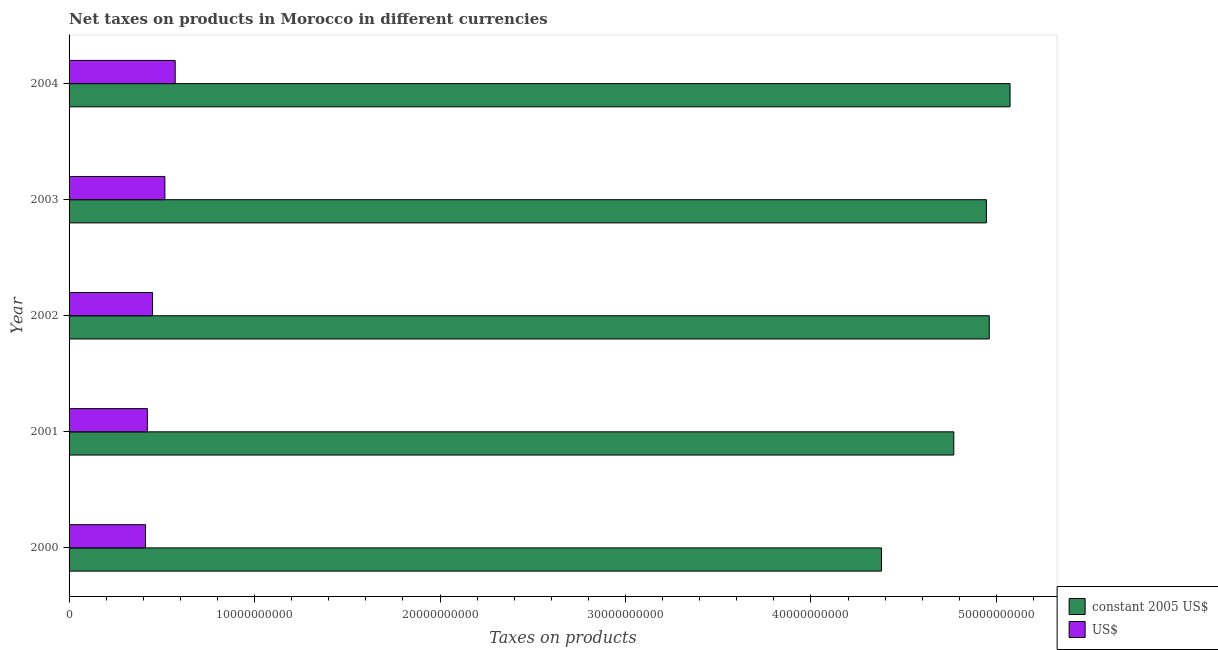How many different coloured bars are there?
Offer a terse response. 2. How many groups of bars are there?
Offer a very short reply. 5. Are the number of bars on each tick of the Y-axis equal?
Make the answer very short. Yes. What is the net taxes in us$ in 2001?
Keep it short and to the point. 4.22e+09. Across all years, what is the maximum net taxes in constant 2005 us$?
Offer a terse response. 5.07e+1. Across all years, what is the minimum net taxes in us$?
Offer a terse response. 4.12e+09. What is the total net taxes in constant 2005 us$ in the graph?
Provide a short and direct response. 2.41e+11. What is the difference between the net taxes in constant 2005 us$ in 2002 and that in 2004?
Offer a very short reply. -1.12e+09. What is the difference between the net taxes in constant 2005 us$ in 2002 and the net taxes in us$ in 2004?
Your response must be concise. 4.39e+1. What is the average net taxes in constant 2005 us$ per year?
Ensure brevity in your answer.  4.83e+1. In the year 2003, what is the difference between the net taxes in constant 2005 us$ and net taxes in us$?
Provide a succinct answer. 4.43e+1. In how many years, is the net taxes in us$ greater than 2000000000 units?
Keep it short and to the point. 5. What is the ratio of the net taxes in us$ in 2001 to that in 2003?
Keep it short and to the point. 0.82. Is the difference between the net taxes in us$ in 2000 and 2001 greater than the difference between the net taxes in constant 2005 us$ in 2000 and 2001?
Offer a very short reply. Yes. What is the difference between the highest and the second highest net taxes in constant 2005 us$?
Provide a short and direct response. 1.12e+09. What is the difference between the highest and the lowest net taxes in us$?
Your answer should be very brief. 1.60e+09. In how many years, is the net taxes in constant 2005 us$ greater than the average net taxes in constant 2005 us$ taken over all years?
Offer a terse response. 3. What does the 1st bar from the top in 2000 represents?
Offer a very short reply. US$. What does the 1st bar from the bottom in 2003 represents?
Keep it short and to the point. Constant 2005 us$. How many bars are there?
Make the answer very short. 10. Are all the bars in the graph horizontal?
Your answer should be compact. Yes. What is the difference between two consecutive major ticks on the X-axis?
Make the answer very short. 1.00e+1. Are the values on the major ticks of X-axis written in scientific E-notation?
Provide a succinct answer. No. Does the graph contain grids?
Your answer should be compact. No. Where does the legend appear in the graph?
Your response must be concise. Bottom right. What is the title of the graph?
Offer a very short reply. Net taxes on products in Morocco in different currencies. What is the label or title of the X-axis?
Offer a terse response. Taxes on products. What is the Taxes on products of constant 2005 US$ in 2000?
Give a very brief answer. 4.38e+1. What is the Taxes on products in US$ in 2000?
Your answer should be very brief. 4.12e+09. What is the Taxes on products in constant 2005 US$ in 2001?
Ensure brevity in your answer.  4.77e+1. What is the Taxes on products in US$ in 2001?
Your answer should be very brief. 4.22e+09. What is the Taxes on products in constant 2005 US$ in 2002?
Give a very brief answer. 4.96e+1. What is the Taxes on products of US$ in 2002?
Your answer should be very brief. 4.50e+09. What is the Taxes on products in constant 2005 US$ in 2003?
Offer a terse response. 4.95e+1. What is the Taxes on products in US$ in 2003?
Make the answer very short. 5.17e+09. What is the Taxes on products in constant 2005 US$ in 2004?
Provide a succinct answer. 5.07e+1. What is the Taxes on products of US$ in 2004?
Your answer should be very brief. 5.72e+09. Across all years, what is the maximum Taxes on products of constant 2005 US$?
Offer a very short reply. 5.07e+1. Across all years, what is the maximum Taxes on products in US$?
Your answer should be very brief. 5.72e+09. Across all years, what is the minimum Taxes on products of constant 2005 US$?
Make the answer very short. 4.38e+1. Across all years, what is the minimum Taxes on products of US$?
Offer a terse response. 4.12e+09. What is the total Taxes on products of constant 2005 US$ in the graph?
Your response must be concise. 2.41e+11. What is the total Taxes on products in US$ in the graph?
Ensure brevity in your answer.  2.37e+1. What is the difference between the Taxes on products of constant 2005 US$ in 2000 and that in 2001?
Make the answer very short. -3.90e+09. What is the difference between the Taxes on products of US$ in 2000 and that in 2001?
Keep it short and to the point. -9.79e+07. What is the difference between the Taxes on products of constant 2005 US$ in 2000 and that in 2002?
Your answer should be compact. -5.81e+09. What is the difference between the Taxes on products in US$ in 2000 and that in 2002?
Keep it short and to the point. -3.79e+08. What is the difference between the Taxes on products in constant 2005 US$ in 2000 and that in 2003?
Provide a short and direct response. -5.65e+09. What is the difference between the Taxes on products in US$ in 2000 and that in 2003?
Give a very brief answer. -1.04e+09. What is the difference between the Taxes on products of constant 2005 US$ in 2000 and that in 2004?
Your response must be concise. -6.93e+09. What is the difference between the Taxes on products of US$ in 2000 and that in 2004?
Provide a short and direct response. -1.60e+09. What is the difference between the Taxes on products of constant 2005 US$ in 2001 and that in 2002?
Your answer should be compact. -1.91e+09. What is the difference between the Taxes on products in US$ in 2001 and that in 2002?
Keep it short and to the point. -2.81e+08. What is the difference between the Taxes on products in constant 2005 US$ in 2001 and that in 2003?
Your response must be concise. -1.76e+09. What is the difference between the Taxes on products in US$ in 2001 and that in 2003?
Keep it short and to the point. -9.45e+08. What is the difference between the Taxes on products of constant 2005 US$ in 2001 and that in 2004?
Offer a very short reply. -3.03e+09. What is the difference between the Taxes on products in US$ in 2001 and that in 2004?
Ensure brevity in your answer.  -1.50e+09. What is the difference between the Taxes on products of constant 2005 US$ in 2002 and that in 2003?
Your answer should be very brief. 1.55e+08. What is the difference between the Taxes on products of US$ in 2002 and that in 2003?
Provide a short and direct response. -6.64e+08. What is the difference between the Taxes on products in constant 2005 US$ in 2002 and that in 2004?
Offer a terse response. -1.12e+09. What is the difference between the Taxes on products of US$ in 2002 and that in 2004?
Your answer should be compact. -1.22e+09. What is the difference between the Taxes on products in constant 2005 US$ in 2003 and that in 2004?
Offer a terse response. -1.28e+09. What is the difference between the Taxes on products in US$ in 2003 and that in 2004?
Offer a terse response. -5.55e+08. What is the difference between the Taxes on products of constant 2005 US$ in 2000 and the Taxes on products of US$ in 2001?
Make the answer very short. 3.96e+1. What is the difference between the Taxes on products in constant 2005 US$ in 2000 and the Taxes on products in US$ in 2002?
Make the answer very short. 3.93e+1. What is the difference between the Taxes on products in constant 2005 US$ in 2000 and the Taxes on products in US$ in 2003?
Give a very brief answer. 3.86e+1. What is the difference between the Taxes on products in constant 2005 US$ in 2000 and the Taxes on products in US$ in 2004?
Your response must be concise. 3.81e+1. What is the difference between the Taxes on products in constant 2005 US$ in 2001 and the Taxes on products in US$ in 2002?
Your answer should be compact. 4.32e+1. What is the difference between the Taxes on products of constant 2005 US$ in 2001 and the Taxes on products of US$ in 2003?
Offer a terse response. 4.25e+1. What is the difference between the Taxes on products in constant 2005 US$ in 2001 and the Taxes on products in US$ in 2004?
Give a very brief answer. 4.20e+1. What is the difference between the Taxes on products of constant 2005 US$ in 2002 and the Taxes on products of US$ in 2003?
Provide a short and direct response. 4.44e+1. What is the difference between the Taxes on products of constant 2005 US$ in 2002 and the Taxes on products of US$ in 2004?
Provide a succinct answer. 4.39e+1. What is the difference between the Taxes on products of constant 2005 US$ in 2003 and the Taxes on products of US$ in 2004?
Offer a very short reply. 4.37e+1. What is the average Taxes on products of constant 2005 US$ per year?
Your answer should be very brief. 4.83e+1. What is the average Taxes on products of US$ per year?
Your response must be concise. 4.75e+09. In the year 2000, what is the difference between the Taxes on products of constant 2005 US$ and Taxes on products of US$?
Offer a very short reply. 3.97e+1. In the year 2001, what is the difference between the Taxes on products of constant 2005 US$ and Taxes on products of US$?
Your answer should be compact. 4.35e+1. In the year 2002, what is the difference between the Taxes on products in constant 2005 US$ and Taxes on products in US$?
Give a very brief answer. 4.51e+1. In the year 2003, what is the difference between the Taxes on products in constant 2005 US$ and Taxes on products in US$?
Make the answer very short. 4.43e+1. In the year 2004, what is the difference between the Taxes on products in constant 2005 US$ and Taxes on products in US$?
Offer a terse response. 4.50e+1. What is the ratio of the Taxes on products in constant 2005 US$ in 2000 to that in 2001?
Your answer should be very brief. 0.92. What is the ratio of the Taxes on products in US$ in 2000 to that in 2001?
Your answer should be compact. 0.98. What is the ratio of the Taxes on products in constant 2005 US$ in 2000 to that in 2002?
Your answer should be very brief. 0.88. What is the ratio of the Taxes on products in US$ in 2000 to that in 2002?
Ensure brevity in your answer.  0.92. What is the ratio of the Taxes on products of constant 2005 US$ in 2000 to that in 2003?
Offer a very short reply. 0.89. What is the ratio of the Taxes on products in US$ in 2000 to that in 2003?
Ensure brevity in your answer.  0.8. What is the ratio of the Taxes on products of constant 2005 US$ in 2000 to that in 2004?
Your response must be concise. 0.86. What is the ratio of the Taxes on products of US$ in 2000 to that in 2004?
Offer a very short reply. 0.72. What is the ratio of the Taxes on products in constant 2005 US$ in 2001 to that in 2002?
Your answer should be very brief. 0.96. What is the ratio of the Taxes on products in US$ in 2001 to that in 2002?
Give a very brief answer. 0.94. What is the ratio of the Taxes on products of constant 2005 US$ in 2001 to that in 2003?
Give a very brief answer. 0.96. What is the ratio of the Taxes on products in US$ in 2001 to that in 2003?
Provide a short and direct response. 0.82. What is the ratio of the Taxes on products of constant 2005 US$ in 2001 to that in 2004?
Keep it short and to the point. 0.94. What is the ratio of the Taxes on products of US$ in 2001 to that in 2004?
Your answer should be compact. 0.74. What is the ratio of the Taxes on products in US$ in 2002 to that in 2003?
Keep it short and to the point. 0.87. What is the ratio of the Taxes on products of constant 2005 US$ in 2002 to that in 2004?
Your answer should be very brief. 0.98. What is the ratio of the Taxes on products of US$ in 2002 to that in 2004?
Offer a very short reply. 0.79. What is the ratio of the Taxes on products of constant 2005 US$ in 2003 to that in 2004?
Your answer should be compact. 0.97. What is the ratio of the Taxes on products in US$ in 2003 to that in 2004?
Keep it short and to the point. 0.9. What is the difference between the highest and the second highest Taxes on products in constant 2005 US$?
Give a very brief answer. 1.12e+09. What is the difference between the highest and the second highest Taxes on products of US$?
Keep it short and to the point. 5.55e+08. What is the difference between the highest and the lowest Taxes on products of constant 2005 US$?
Make the answer very short. 6.93e+09. What is the difference between the highest and the lowest Taxes on products of US$?
Offer a terse response. 1.60e+09. 